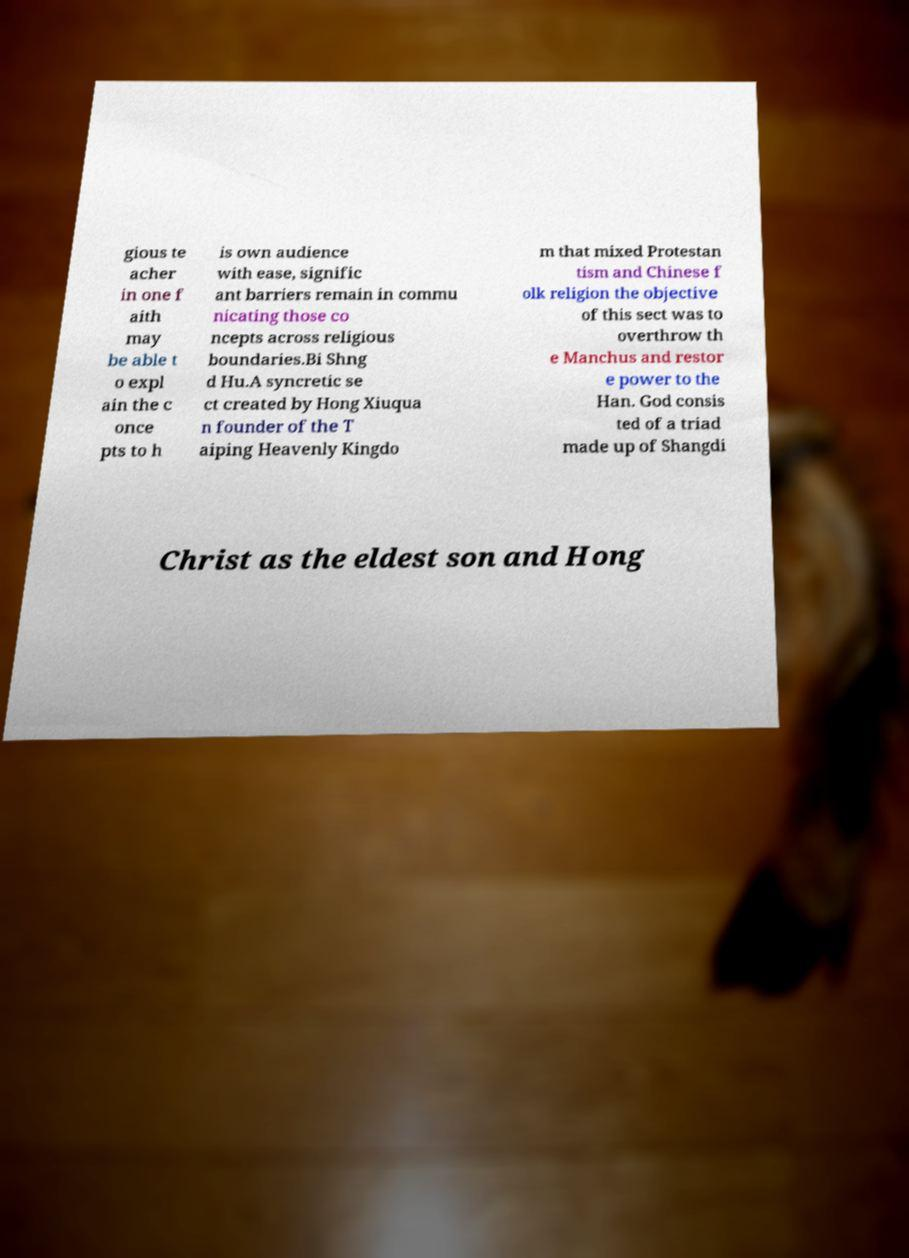There's text embedded in this image that I need extracted. Can you transcribe it verbatim? gious te acher in one f aith may be able t o expl ain the c once pts to h is own audience with ease, signific ant barriers remain in commu nicating those co ncepts across religious boundaries.Bi Shng d Hu.A syncretic se ct created by Hong Xiuqua n founder of the T aiping Heavenly Kingdo m that mixed Protestan tism and Chinese f olk religion the objective of this sect was to overthrow th e Manchus and restor e power to the Han. God consis ted of a triad made up of Shangdi Christ as the eldest son and Hong 